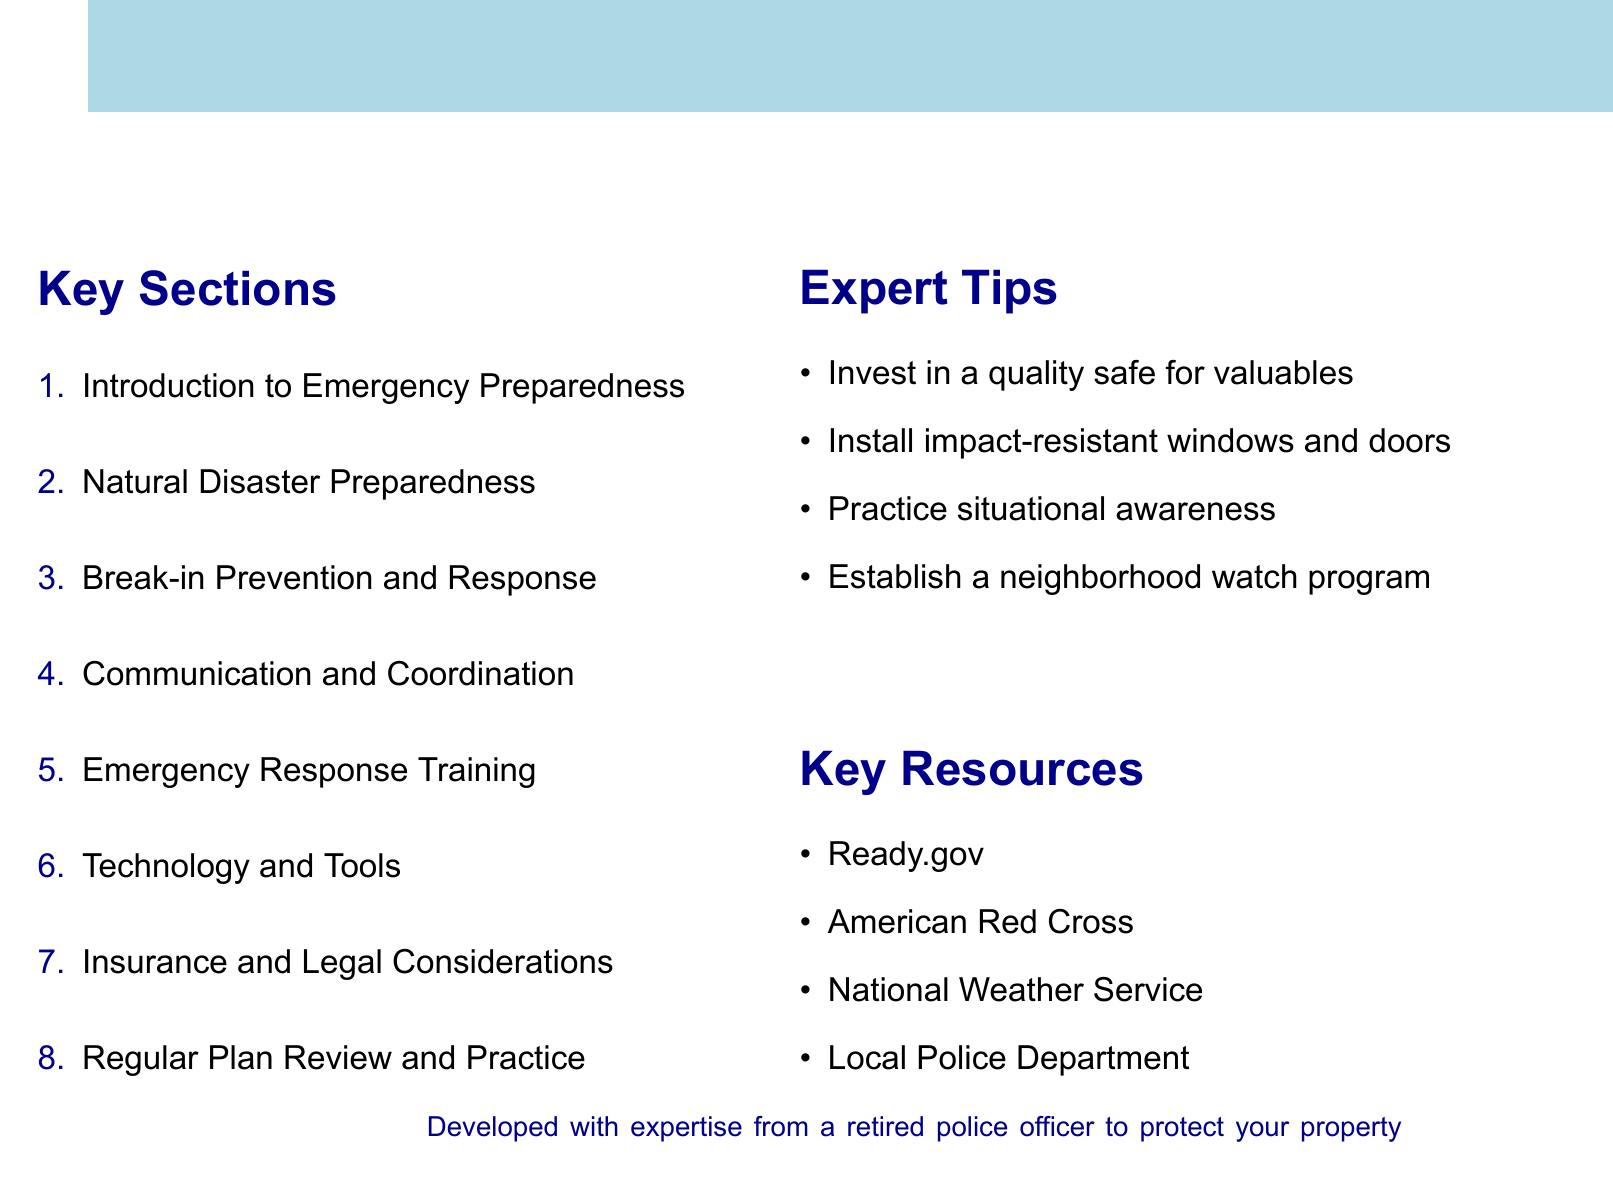what is the focus of the agenda? The agenda focuses on developing an emergency preparedness plan for new homeowners, addressing various scenarios including natural disasters and break-ins.
Answer: Emergency Preparedness Plan how many key sections are outlined in the document? There are eight key sections listed in the agenda.
Answer: 8 what is a recommended item to include in a disaster supply kit? The agenda suggests creating a disaster supply kit that is essential for natural disaster preparedness.
Answer: Disaster Supply Kit who provides emergency preparedness training and resources? The American Red Cross is mentioned as a key resource for disaster preparedness training.
Answer: American Red Cross what is one suggested tip for break-in prevention? The document advises on home security assessments as a way to prevent break-ins.
Answer: Home Security Assessment what type of communication plan should families establish? Families should establish a family communication plan to coordinate during emergencies.
Answer: Family Communication Plan which section includes home safety techniques? Emergency response training includes self-defense techniques for home protection.
Answer: Emergency Response Training how often should emergency drills be scheduled? The document recommends scheduling bi-annual emergency drills to review the preparedness plan.
Answer: Bi-annual what is a key resource for real-time weather alerts? The National Weather Service provides real-time weather alerts and forecasts.
Answer: National Weather Service 